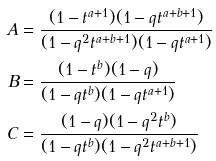<formula> <loc_0><loc_0><loc_500><loc_500>A & = \frac { ( 1 - t ^ { a + 1 } ) ( 1 - q t ^ { a + b + 1 } ) } { ( 1 - q ^ { 2 } t ^ { a + b + 1 } ) ( 1 - q t ^ { a + 1 } ) } \\ B & = \frac { ( 1 - t ^ { b } ) ( 1 - q ) } { ( 1 - q t ^ { b } ) ( 1 - q t ^ { a + 1 } ) } \\ C & = \frac { ( 1 - q ) ( 1 - q ^ { 2 } t ^ { b } ) } { ( 1 - q t ^ { b } ) ( 1 - q ^ { 2 } t ^ { a + b + 1 } ) }</formula> 